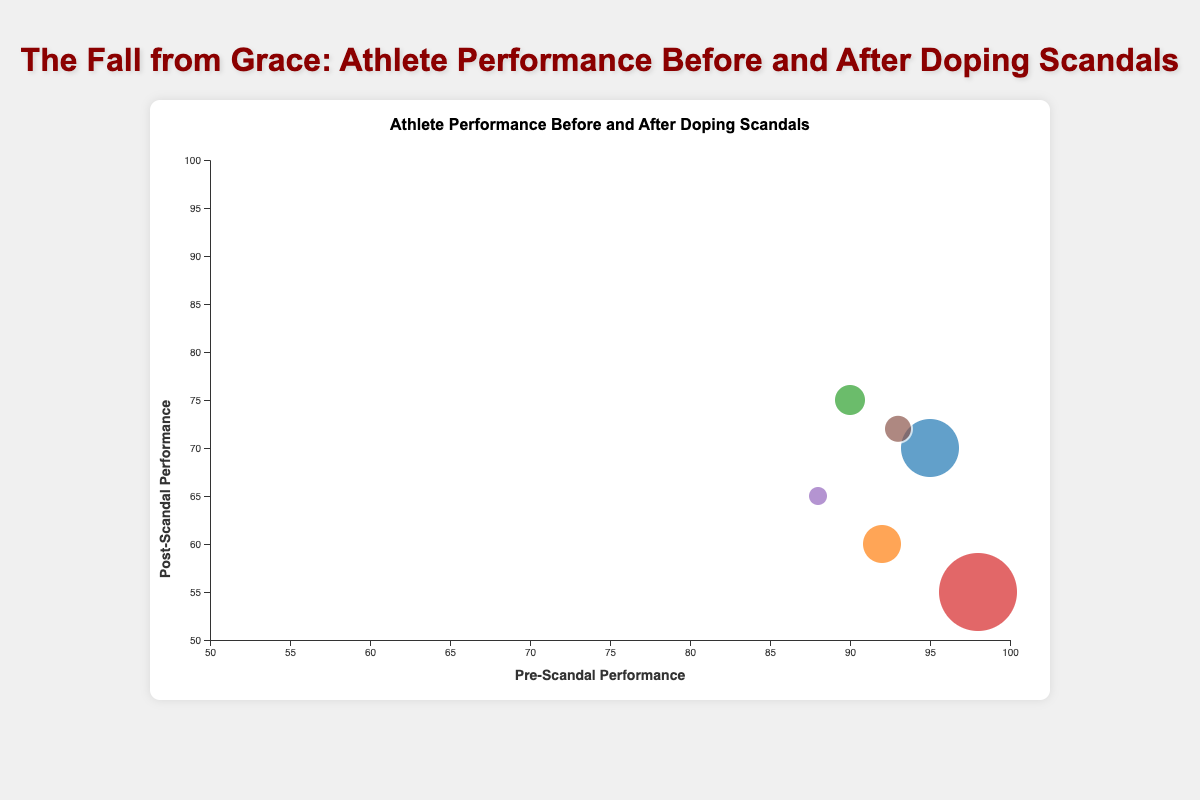Which athlete has the highest pre-scandal performance? To find the highest pre-scandal performance, look at the x-axis values and find the data point with the highest value. Ben Johnson has a pre-scandal performance of 98, which is the highest among all athletes.
Answer: Ben Johnson Which athlete experienced the largest drop in performance after their doping scandal? The largest drop in performance can be calculated by taking the difference between pre-scandal and post-scandal performance and finding the maximum drop. Ben Johnson has the largest drop: 98 (pre) - 55 (post) = 43.
Answer: Ben Johnson How many athletes have a post-scandal performance lower than 70? Look at the y-axis values and count the bubbles that are positioned below the y=70 line. Lance Armstrong, Marion Jones, and Ben Johnson have post-scandal performances lower than 70.
Answer: 3 What is the average pre-scandal performance of all athletes? Sum all pre-scandal performances and divide by the number of athletes: (95 + 92 + 90 + 98 + 88 + 93)/6 = 556/6 = 92.67
Answer: 92.67 Who has the highest scandal impact score? Scandal impact score is represented by the size of the bubbles. Ben Johnson has the largest bubble, indicating the highest scandal impact score of 90.
Answer: Ben Johnson Which athlete has a higher post-scandal performance, Alex Rodriguez or Maria Sharapova? Compare the y-axis positions of the bubbles for Alex Rodriguez and Maria Sharapova. Alex Rodriguez has a post-scandal performance of 75, whereas Maria Sharapova has 65.
Answer: Alex Rodriguez What is the average post-scandal performance for athletes who doped after 2005? Calculate the average for athletes who doped after 2005: post-scandal performances for Armstrong (70), Rodriguez (75), Sharapova (65), and Gay (72) sum to 282, divided by 4 athletes: 282/4 = 70.5.
Answer: 70.5 Which athlete has the closest pre and post-scandal performance values? Measure the difference between pre and post-scandal performance for each athlete and identify the smallest difference. Alex Rodriguez has the smallest difference of 15 (90 - 75).
Answer: Alex Rodriguez Are any athletes' performance improved post-scandal? Examine if any y-axis (post-scandal performance) value is greater than its corresponding x-axis (pre-scandal performance). None of the athletes' performance improved post-scandal.
Answer: No Which athlete has the smallest scandal impact score among those with pre-scandal performance above 90? Filter the athletes with pre-scandal performance above 90 and find the one with the smallest bubble representing the scandal impact score. Marion Jones has a scandal impact score of 80, the smallest among those with pre-scandal performance above 90.
Answer: Marion Jones 